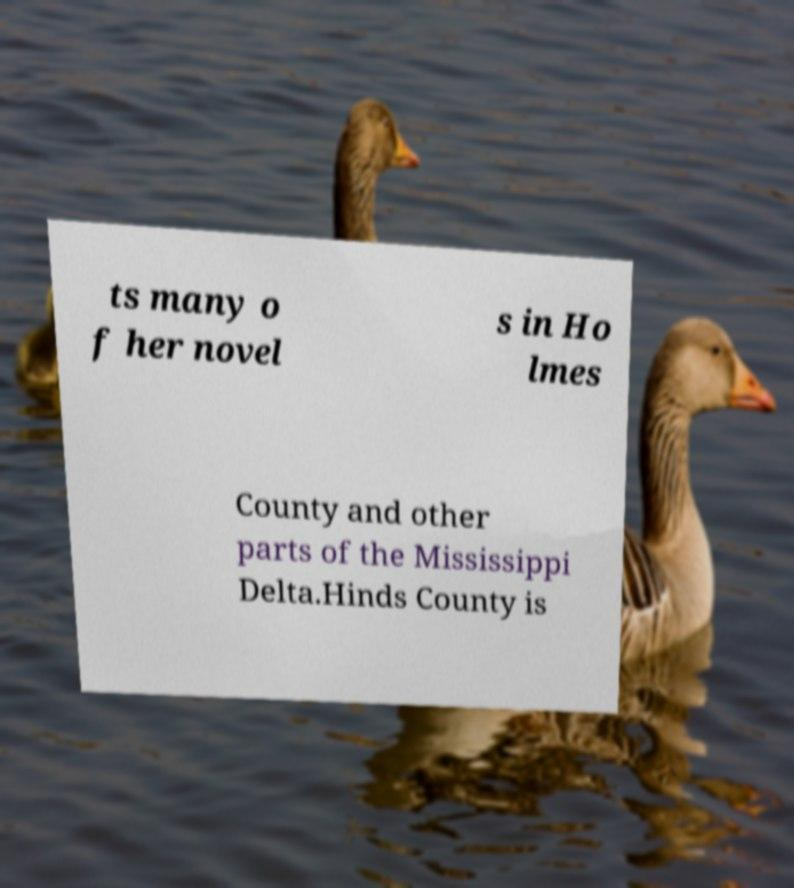There's text embedded in this image that I need extracted. Can you transcribe it verbatim? ts many o f her novel s in Ho lmes County and other parts of the Mississippi Delta.Hinds County is 